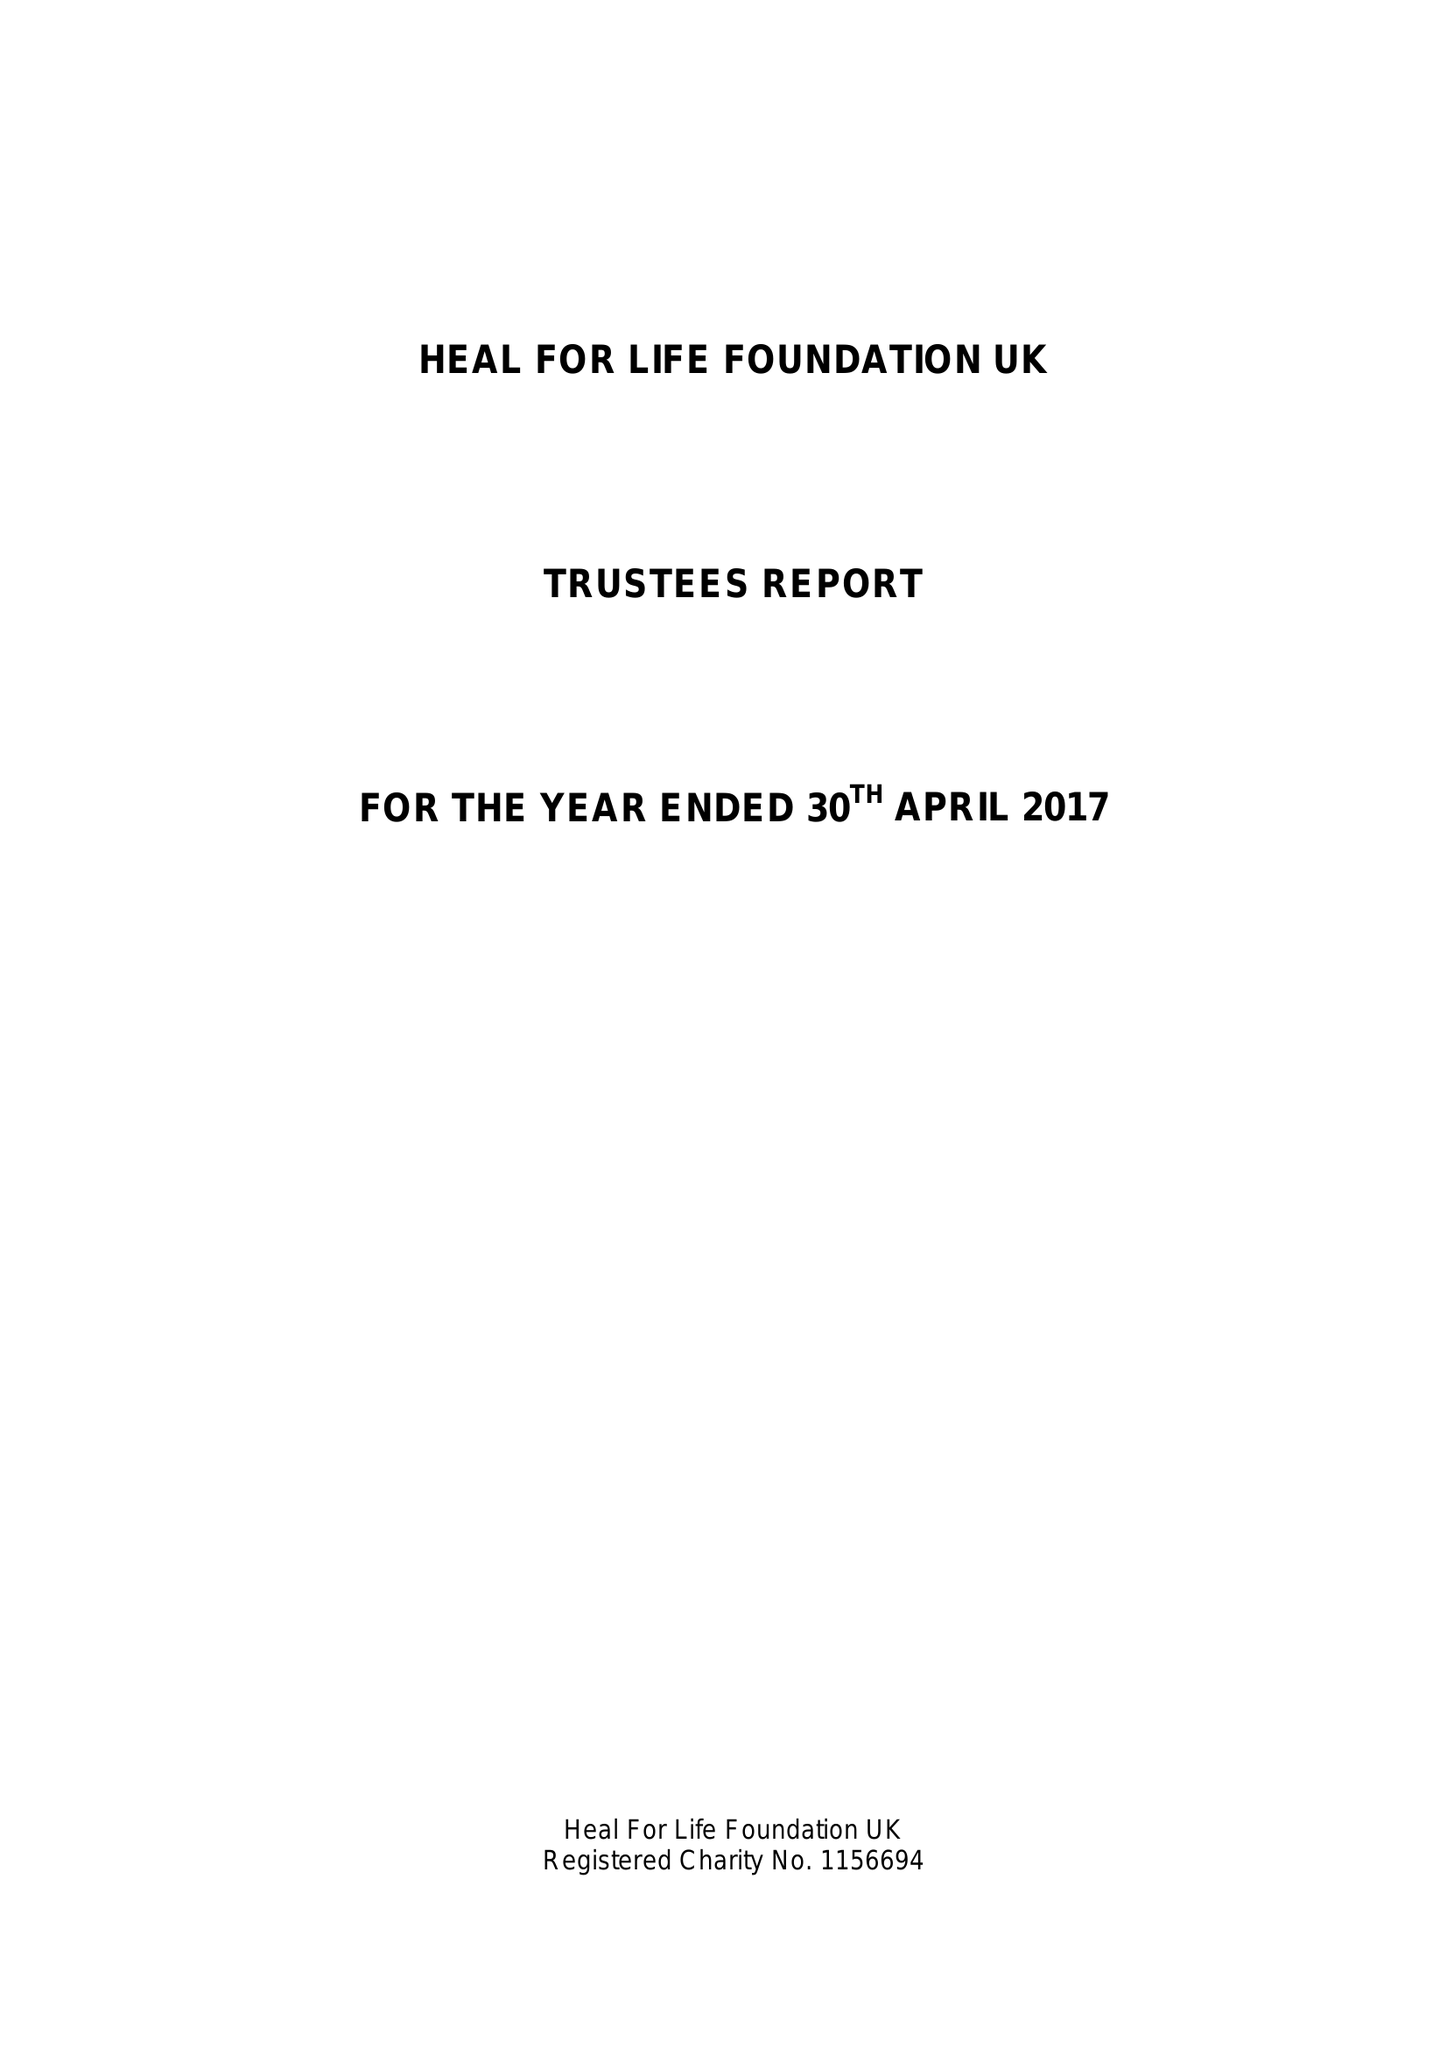What is the value for the income_annually_in_british_pounds?
Answer the question using a single word or phrase. 10763.99 